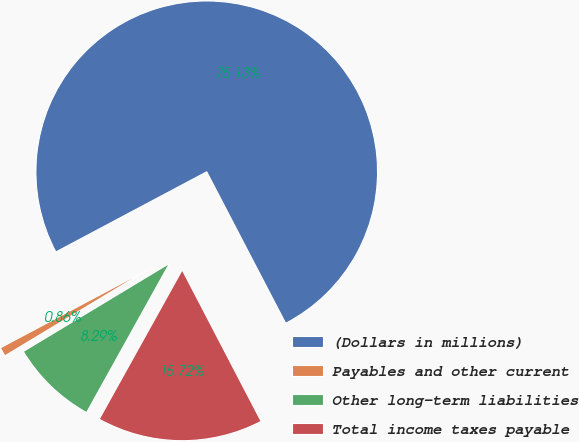Convert chart. <chart><loc_0><loc_0><loc_500><loc_500><pie_chart><fcel>(Dollars in millions)<fcel>Payables and other current<fcel>Other long-term liabilities<fcel>Total income taxes payable<nl><fcel>75.13%<fcel>0.86%<fcel>8.29%<fcel>15.72%<nl></chart> 